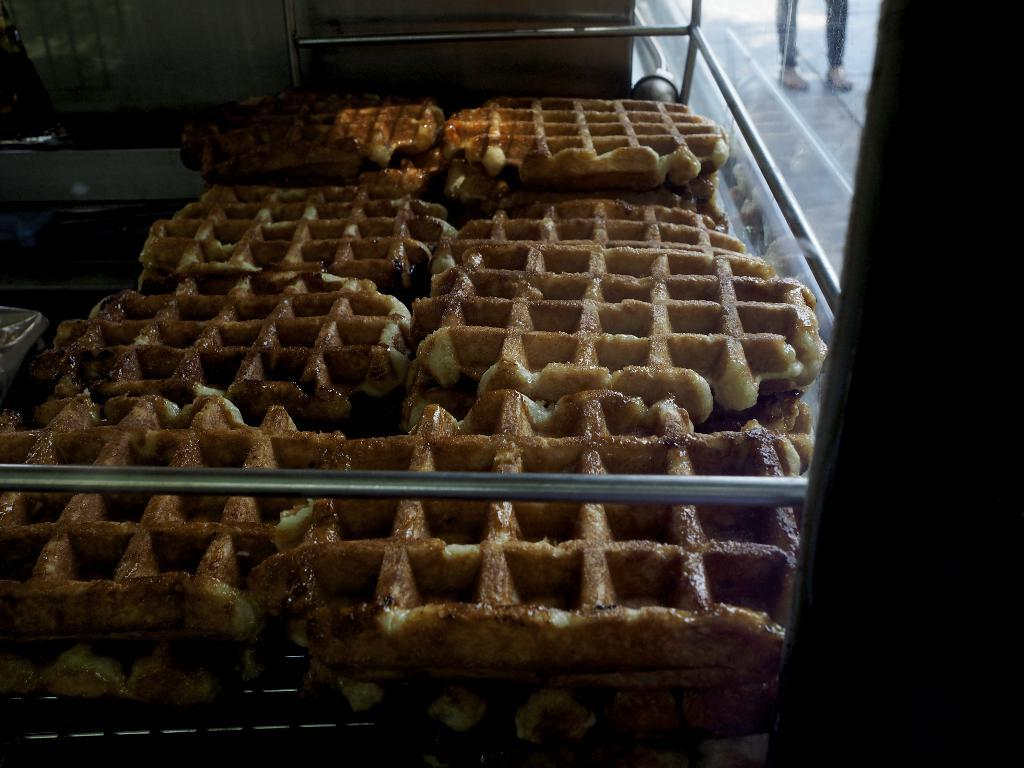What can be seen in the image related to food? There is food in the image. What objects are present in the image that resemble long, thin bars? There are rods in the image. What type of transparent barrier is visible in the image? There is a glass window in the image. Whose legs can be seen through the glass window in the image? Person's legs are visible through the glass window. How many apples are hanging from the rods in the image? There are no apples present in the image; only food, rods, a glass window, and a person's legs are visible. What type of mist can be seen surrounding the glass window in the image? There is no mist present in the image; the glass window is clear and allows for a view of the person's legs. 